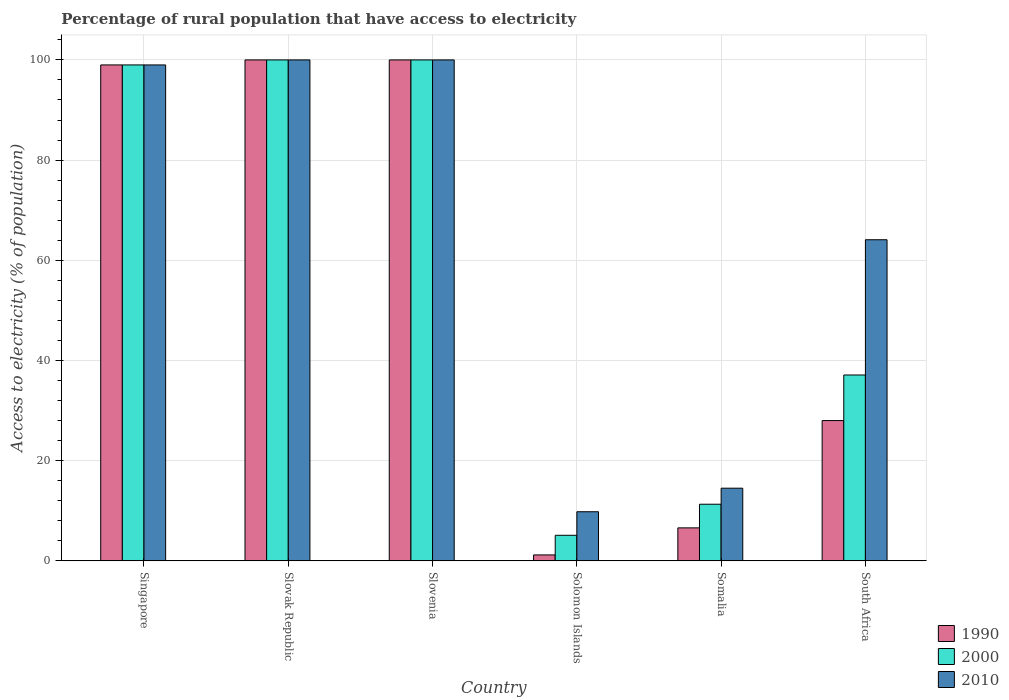How many different coloured bars are there?
Your answer should be compact. 3. How many groups of bars are there?
Provide a succinct answer. 6. How many bars are there on the 2nd tick from the left?
Your answer should be very brief. 3. What is the label of the 6th group of bars from the left?
Your response must be concise. South Africa. Across all countries, what is the minimum percentage of rural population that have access to electricity in 2010?
Provide a succinct answer. 9.8. In which country was the percentage of rural population that have access to electricity in 2010 maximum?
Offer a very short reply. Slovak Republic. In which country was the percentage of rural population that have access to electricity in 2010 minimum?
Ensure brevity in your answer.  Solomon Islands. What is the total percentage of rural population that have access to electricity in 1990 in the graph?
Ensure brevity in your answer.  334.76. What is the difference between the percentage of rural population that have access to electricity in 2010 in Slovenia and that in Somalia?
Keep it short and to the point. 85.5. What is the difference between the percentage of rural population that have access to electricity in 2010 in South Africa and the percentage of rural population that have access to electricity in 1990 in Slovak Republic?
Provide a succinct answer. -35.9. What is the average percentage of rural population that have access to electricity in 1990 per country?
Provide a succinct answer. 55.79. What is the difference between the percentage of rural population that have access to electricity of/in 2010 and percentage of rural population that have access to electricity of/in 2000 in Slovenia?
Make the answer very short. 0. What is the ratio of the percentage of rural population that have access to electricity in 2010 in Slovenia to that in Solomon Islands?
Offer a very short reply. 10.2. Is the percentage of rural population that have access to electricity in 2010 in Slovak Republic less than that in South Africa?
Your answer should be compact. No. Is the difference between the percentage of rural population that have access to electricity in 2010 in Somalia and South Africa greater than the difference between the percentage of rural population that have access to electricity in 2000 in Somalia and South Africa?
Your response must be concise. No. What is the difference between the highest and the second highest percentage of rural population that have access to electricity in 2010?
Your answer should be compact. -1. What is the difference between the highest and the lowest percentage of rural population that have access to electricity in 1990?
Provide a succinct answer. 98.82. What does the 2nd bar from the right in South Africa represents?
Your answer should be very brief. 2000. How many bars are there?
Your answer should be compact. 18. What is the difference between two consecutive major ticks on the Y-axis?
Make the answer very short. 20. Does the graph contain any zero values?
Your response must be concise. No. Where does the legend appear in the graph?
Offer a very short reply. Bottom right. What is the title of the graph?
Give a very brief answer. Percentage of rural population that have access to electricity. Does "1970" appear as one of the legend labels in the graph?
Ensure brevity in your answer.  No. What is the label or title of the X-axis?
Ensure brevity in your answer.  Country. What is the label or title of the Y-axis?
Your answer should be very brief. Access to electricity (% of population). What is the Access to electricity (% of population) of 1990 in Singapore?
Offer a terse response. 99. What is the Access to electricity (% of population) of 2000 in Singapore?
Make the answer very short. 99. What is the Access to electricity (% of population) of 2010 in Singapore?
Provide a succinct answer. 99. What is the Access to electricity (% of population) of 1990 in Slovak Republic?
Keep it short and to the point. 100. What is the Access to electricity (% of population) in 2000 in Slovak Republic?
Make the answer very short. 100. What is the Access to electricity (% of population) in 1990 in Slovenia?
Offer a very short reply. 100. What is the Access to electricity (% of population) of 1990 in Solomon Islands?
Keep it short and to the point. 1.18. What is the Access to electricity (% of population) in 2000 in Solomon Islands?
Provide a succinct answer. 5.1. What is the Access to electricity (% of population) in 2010 in Solomon Islands?
Give a very brief answer. 9.8. What is the Access to electricity (% of population) of 1990 in Somalia?
Your answer should be very brief. 6.58. What is the Access to electricity (% of population) in 2000 in Somalia?
Your response must be concise. 11.3. What is the Access to electricity (% of population) of 1990 in South Africa?
Your response must be concise. 28. What is the Access to electricity (% of population) in 2000 in South Africa?
Provide a succinct answer. 37.1. What is the Access to electricity (% of population) of 2010 in South Africa?
Make the answer very short. 64.1. Across all countries, what is the minimum Access to electricity (% of population) in 1990?
Your answer should be very brief. 1.18. Across all countries, what is the minimum Access to electricity (% of population) in 2000?
Give a very brief answer. 5.1. What is the total Access to electricity (% of population) in 1990 in the graph?
Ensure brevity in your answer.  334.76. What is the total Access to electricity (% of population) of 2000 in the graph?
Your answer should be very brief. 352.5. What is the total Access to electricity (% of population) in 2010 in the graph?
Your response must be concise. 387.4. What is the difference between the Access to electricity (% of population) of 1990 in Singapore and that in Slovak Republic?
Ensure brevity in your answer.  -1. What is the difference between the Access to electricity (% of population) of 2000 in Singapore and that in Slovak Republic?
Ensure brevity in your answer.  -1. What is the difference between the Access to electricity (% of population) in 2000 in Singapore and that in Slovenia?
Provide a succinct answer. -1. What is the difference between the Access to electricity (% of population) in 1990 in Singapore and that in Solomon Islands?
Your response must be concise. 97.82. What is the difference between the Access to electricity (% of population) in 2000 in Singapore and that in Solomon Islands?
Offer a very short reply. 93.9. What is the difference between the Access to electricity (% of population) of 2010 in Singapore and that in Solomon Islands?
Provide a succinct answer. 89.2. What is the difference between the Access to electricity (% of population) in 1990 in Singapore and that in Somalia?
Your answer should be very brief. 92.42. What is the difference between the Access to electricity (% of population) in 2000 in Singapore and that in Somalia?
Provide a succinct answer. 87.7. What is the difference between the Access to electricity (% of population) in 2010 in Singapore and that in Somalia?
Ensure brevity in your answer.  84.5. What is the difference between the Access to electricity (% of population) of 2000 in Singapore and that in South Africa?
Your response must be concise. 61.9. What is the difference between the Access to electricity (% of population) of 2010 in Singapore and that in South Africa?
Offer a terse response. 34.9. What is the difference between the Access to electricity (% of population) of 2000 in Slovak Republic and that in Slovenia?
Provide a succinct answer. 0. What is the difference between the Access to electricity (% of population) of 1990 in Slovak Republic and that in Solomon Islands?
Provide a short and direct response. 98.82. What is the difference between the Access to electricity (% of population) in 2000 in Slovak Republic and that in Solomon Islands?
Make the answer very short. 94.9. What is the difference between the Access to electricity (% of population) in 2010 in Slovak Republic and that in Solomon Islands?
Offer a terse response. 90.2. What is the difference between the Access to electricity (% of population) of 1990 in Slovak Republic and that in Somalia?
Offer a very short reply. 93.42. What is the difference between the Access to electricity (% of population) of 2000 in Slovak Republic and that in Somalia?
Offer a terse response. 88.7. What is the difference between the Access to electricity (% of population) of 2010 in Slovak Republic and that in Somalia?
Offer a very short reply. 85.5. What is the difference between the Access to electricity (% of population) of 2000 in Slovak Republic and that in South Africa?
Your response must be concise. 62.9. What is the difference between the Access to electricity (% of population) in 2010 in Slovak Republic and that in South Africa?
Offer a very short reply. 35.9. What is the difference between the Access to electricity (% of population) in 1990 in Slovenia and that in Solomon Islands?
Your answer should be compact. 98.82. What is the difference between the Access to electricity (% of population) of 2000 in Slovenia and that in Solomon Islands?
Provide a succinct answer. 94.9. What is the difference between the Access to electricity (% of population) of 2010 in Slovenia and that in Solomon Islands?
Keep it short and to the point. 90.2. What is the difference between the Access to electricity (% of population) of 1990 in Slovenia and that in Somalia?
Offer a terse response. 93.42. What is the difference between the Access to electricity (% of population) in 2000 in Slovenia and that in Somalia?
Provide a short and direct response. 88.7. What is the difference between the Access to electricity (% of population) of 2010 in Slovenia and that in Somalia?
Keep it short and to the point. 85.5. What is the difference between the Access to electricity (% of population) of 1990 in Slovenia and that in South Africa?
Give a very brief answer. 72. What is the difference between the Access to electricity (% of population) of 2000 in Slovenia and that in South Africa?
Your answer should be very brief. 62.9. What is the difference between the Access to electricity (% of population) in 2010 in Slovenia and that in South Africa?
Ensure brevity in your answer.  35.9. What is the difference between the Access to electricity (% of population) in 1990 in Solomon Islands and that in Somalia?
Your answer should be compact. -5.4. What is the difference between the Access to electricity (% of population) of 2000 in Solomon Islands and that in Somalia?
Your response must be concise. -6.2. What is the difference between the Access to electricity (% of population) in 2010 in Solomon Islands and that in Somalia?
Ensure brevity in your answer.  -4.7. What is the difference between the Access to electricity (% of population) in 1990 in Solomon Islands and that in South Africa?
Make the answer very short. -26.82. What is the difference between the Access to electricity (% of population) in 2000 in Solomon Islands and that in South Africa?
Your response must be concise. -32. What is the difference between the Access to electricity (% of population) in 2010 in Solomon Islands and that in South Africa?
Offer a terse response. -54.3. What is the difference between the Access to electricity (% of population) in 1990 in Somalia and that in South Africa?
Give a very brief answer. -21.42. What is the difference between the Access to electricity (% of population) of 2000 in Somalia and that in South Africa?
Provide a short and direct response. -25.8. What is the difference between the Access to electricity (% of population) of 2010 in Somalia and that in South Africa?
Your answer should be compact. -49.6. What is the difference between the Access to electricity (% of population) in 1990 in Singapore and the Access to electricity (% of population) in 2010 in Slovak Republic?
Give a very brief answer. -1. What is the difference between the Access to electricity (% of population) in 1990 in Singapore and the Access to electricity (% of population) in 2010 in Slovenia?
Make the answer very short. -1. What is the difference between the Access to electricity (% of population) in 2000 in Singapore and the Access to electricity (% of population) in 2010 in Slovenia?
Your answer should be compact. -1. What is the difference between the Access to electricity (% of population) in 1990 in Singapore and the Access to electricity (% of population) in 2000 in Solomon Islands?
Provide a short and direct response. 93.9. What is the difference between the Access to electricity (% of population) of 1990 in Singapore and the Access to electricity (% of population) of 2010 in Solomon Islands?
Offer a very short reply. 89.2. What is the difference between the Access to electricity (% of population) in 2000 in Singapore and the Access to electricity (% of population) in 2010 in Solomon Islands?
Your response must be concise. 89.2. What is the difference between the Access to electricity (% of population) in 1990 in Singapore and the Access to electricity (% of population) in 2000 in Somalia?
Your answer should be very brief. 87.7. What is the difference between the Access to electricity (% of population) of 1990 in Singapore and the Access to electricity (% of population) of 2010 in Somalia?
Offer a very short reply. 84.5. What is the difference between the Access to electricity (% of population) of 2000 in Singapore and the Access to electricity (% of population) of 2010 in Somalia?
Keep it short and to the point. 84.5. What is the difference between the Access to electricity (% of population) in 1990 in Singapore and the Access to electricity (% of population) in 2000 in South Africa?
Keep it short and to the point. 61.9. What is the difference between the Access to electricity (% of population) in 1990 in Singapore and the Access to electricity (% of population) in 2010 in South Africa?
Your answer should be very brief. 34.9. What is the difference between the Access to electricity (% of population) in 2000 in Singapore and the Access to electricity (% of population) in 2010 in South Africa?
Offer a terse response. 34.9. What is the difference between the Access to electricity (% of population) in 1990 in Slovak Republic and the Access to electricity (% of population) in 2000 in Solomon Islands?
Your answer should be compact. 94.9. What is the difference between the Access to electricity (% of population) in 1990 in Slovak Republic and the Access to electricity (% of population) in 2010 in Solomon Islands?
Give a very brief answer. 90.2. What is the difference between the Access to electricity (% of population) in 2000 in Slovak Republic and the Access to electricity (% of population) in 2010 in Solomon Islands?
Give a very brief answer. 90.2. What is the difference between the Access to electricity (% of population) of 1990 in Slovak Republic and the Access to electricity (% of population) of 2000 in Somalia?
Provide a short and direct response. 88.7. What is the difference between the Access to electricity (% of population) in 1990 in Slovak Republic and the Access to electricity (% of population) in 2010 in Somalia?
Give a very brief answer. 85.5. What is the difference between the Access to electricity (% of population) of 2000 in Slovak Republic and the Access to electricity (% of population) of 2010 in Somalia?
Offer a terse response. 85.5. What is the difference between the Access to electricity (% of population) of 1990 in Slovak Republic and the Access to electricity (% of population) of 2000 in South Africa?
Your answer should be very brief. 62.9. What is the difference between the Access to electricity (% of population) of 1990 in Slovak Republic and the Access to electricity (% of population) of 2010 in South Africa?
Your answer should be compact. 35.9. What is the difference between the Access to electricity (% of population) of 2000 in Slovak Republic and the Access to electricity (% of population) of 2010 in South Africa?
Provide a short and direct response. 35.9. What is the difference between the Access to electricity (% of population) of 1990 in Slovenia and the Access to electricity (% of population) of 2000 in Solomon Islands?
Make the answer very short. 94.9. What is the difference between the Access to electricity (% of population) of 1990 in Slovenia and the Access to electricity (% of population) of 2010 in Solomon Islands?
Provide a succinct answer. 90.2. What is the difference between the Access to electricity (% of population) of 2000 in Slovenia and the Access to electricity (% of population) of 2010 in Solomon Islands?
Your answer should be compact. 90.2. What is the difference between the Access to electricity (% of population) of 1990 in Slovenia and the Access to electricity (% of population) of 2000 in Somalia?
Provide a succinct answer. 88.7. What is the difference between the Access to electricity (% of population) in 1990 in Slovenia and the Access to electricity (% of population) in 2010 in Somalia?
Offer a terse response. 85.5. What is the difference between the Access to electricity (% of population) of 2000 in Slovenia and the Access to electricity (% of population) of 2010 in Somalia?
Keep it short and to the point. 85.5. What is the difference between the Access to electricity (% of population) in 1990 in Slovenia and the Access to electricity (% of population) in 2000 in South Africa?
Your response must be concise. 62.9. What is the difference between the Access to electricity (% of population) in 1990 in Slovenia and the Access to electricity (% of population) in 2010 in South Africa?
Provide a short and direct response. 35.9. What is the difference between the Access to electricity (% of population) of 2000 in Slovenia and the Access to electricity (% of population) of 2010 in South Africa?
Give a very brief answer. 35.9. What is the difference between the Access to electricity (% of population) in 1990 in Solomon Islands and the Access to electricity (% of population) in 2000 in Somalia?
Offer a terse response. -10.12. What is the difference between the Access to electricity (% of population) in 1990 in Solomon Islands and the Access to electricity (% of population) in 2010 in Somalia?
Your response must be concise. -13.32. What is the difference between the Access to electricity (% of population) in 2000 in Solomon Islands and the Access to electricity (% of population) in 2010 in Somalia?
Your answer should be compact. -9.4. What is the difference between the Access to electricity (% of population) in 1990 in Solomon Islands and the Access to electricity (% of population) in 2000 in South Africa?
Make the answer very short. -35.92. What is the difference between the Access to electricity (% of population) of 1990 in Solomon Islands and the Access to electricity (% of population) of 2010 in South Africa?
Keep it short and to the point. -62.92. What is the difference between the Access to electricity (% of population) in 2000 in Solomon Islands and the Access to electricity (% of population) in 2010 in South Africa?
Your answer should be compact. -59. What is the difference between the Access to electricity (% of population) of 1990 in Somalia and the Access to electricity (% of population) of 2000 in South Africa?
Provide a succinct answer. -30.52. What is the difference between the Access to electricity (% of population) in 1990 in Somalia and the Access to electricity (% of population) in 2010 in South Africa?
Provide a succinct answer. -57.52. What is the difference between the Access to electricity (% of population) of 2000 in Somalia and the Access to electricity (% of population) of 2010 in South Africa?
Your answer should be very brief. -52.8. What is the average Access to electricity (% of population) in 1990 per country?
Make the answer very short. 55.79. What is the average Access to electricity (% of population) of 2000 per country?
Your response must be concise. 58.75. What is the average Access to electricity (% of population) of 2010 per country?
Make the answer very short. 64.57. What is the difference between the Access to electricity (% of population) in 1990 and Access to electricity (% of population) in 2000 in Slovak Republic?
Your answer should be very brief. 0. What is the difference between the Access to electricity (% of population) of 2000 and Access to electricity (% of population) of 2010 in Slovak Republic?
Your answer should be compact. 0. What is the difference between the Access to electricity (% of population) of 1990 and Access to electricity (% of population) of 2000 in Solomon Islands?
Provide a short and direct response. -3.92. What is the difference between the Access to electricity (% of population) of 1990 and Access to electricity (% of population) of 2010 in Solomon Islands?
Give a very brief answer. -8.62. What is the difference between the Access to electricity (% of population) in 1990 and Access to electricity (% of population) in 2000 in Somalia?
Your response must be concise. -4.72. What is the difference between the Access to electricity (% of population) in 1990 and Access to electricity (% of population) in 2010 in Somalia?
Provide a short and direct response. -7.92. What is the difference between the Access to electricity (% of population) in 2000 and Access to electricity (% of population) in 2010 in Somalia?
Your answer should be compact. -3.2. What is the difference between the Access to electricity (% of population) in 1990 and Access to electricity (% of population) in 2010 in South Africa?
Ensure brevity in your answer.  -36.1. What is the difference between the Access to electricity (% of population) in 2000 and Access to electricity (% of population) in 2010 in South Africa?
Your response must be concise. -27. What is the ratio of the Access to electricity (% of population) in 1990 in Singapore to that in Slovak Republic?
Provide a short and direct response. 0.99. What is the ratio of the Access to electricity (% of population) of 2010 in Singapore to that in Slovak Republic?
Your answer should be compact. 0.99. What is the ratio of the Access to electricity (% of population) in 1990 in Singapore to that in Solomon Islands?
Offer a terse response. 83.94. What is the ratio of the Access to electricity (% of population) in 2000 in Singapore to that in Solomon Islands?
Offer a very short reply. 19.41. What is the ratio of the Access to electricity (% of population) of 2010 in Singapore to that in Solomon Islands?
Your answer should be very brief. 10.1. What is the ratio of the Access to electricity (% of population) in 1990 in Singapore to that in Somalia?
Keep it short and to the point. 15.05. What is the ratio of the Access to electricity (% of population) in 2000 in Singapore to that in Somalia?
Provide a succinct answer. 8.76. What is the ratio of the Access to electricity (% of population) in 2010 in Singapore to that in Somalia?
Your response must be concise. 6.83. What is the ratio of the Access to electricity (% of population) of 1990 in Singapore to that in South Africa?
Your answer should be compact. 3.54. What is the ratio of the Access to electricity (% of population) in 2000 in Singapore to that in South Africa?
Your response must be concise. 2.67. What is the ratio of the Access to electricity (% of population) in 2010 in Singapore to that in South Africa?
Offer a terse response. 1.54. What is the ratio of the Access to electricity (% of population) in 1990 in Slovak Republic to that in Solomon Islands?
Your answer should be compact. 84.78. What is the ratio of the Access to electricity (% of population) of 2000 in Slovak Republic to that in Solomon Islands?
Your answer should be compact. 19.61. What is the ratio of the Access to electricity (% of population) in 2010 in Slovak Republic to that in Solomon Islands?
Provide a short and direct response. 10.2. What is the ratio of the Access to electricity (% of population) in 1990 in Slovak Republic to that in Somalia?
Ensure brevity in your answer.  15.2. What is the ratio of the Access to electricity (% of population) of 2000 in Slovak Republic to that in Somalia?
Provide a short and direct response. 8.85. What is the ratio of the Access to electricity (% of population) in 2010 in Slovak Republic to that in Somalia?
Make the answer very short. 6.9. What is the ratio of the Access to electricity (% of population) of 1990 in Slovak Republic to that in South Africa?
Your answer should be compact. 3.57. What is the ratio of the Access to electricity (% of population) in 2000 in Slovak Republic to that in South Africa?
Your response must be concise. 2.7. What is the ratio of the Access to electricity (% of population) in 2010 in Slovak Republic to that in South Africa?
Make the answer very short. 1.56. What is the ratio of the Access to electricity (% of population) of 1990 in Slovenia to that in Solomon Islands?
Your answer should be very brief. 84.78. What is the ratio of the Access to electricity (% of population) of 2000 in Slovenia to that in Solomon Islands?
Your answer should be compact. 19.61. What is the ratio of the Access to electricity (% of population) of 2010 in Slovenia to that in Solomon Islands?
Offer a very short reply. 10.2. What is the ratio of the Access to electricity (% of population) in 1990 in Slovenia to that in Somalia?
Ensure brevity in your answer.  15.2. What is the ratio of the Access to electricity (% of population) in 2000 in Slovenia to that in Somalia?
Your answer should be very brief. 8.85. What is the ratio of the Access to electricity (% of population) in 2010 in Slovenia to that in Somalia?
Keep it short and to the point. 6.9. What is the ratio of the Access to electricity (% of population) in 1990 in Slovenia to that in South Africa?
Keep it short and to the point. 3.57. What is the ratio of the Access to electricity (% of population) in 2000 in Slovenia to that in South Africa?
Your answer should be very brief. 2.7. What is the ratio of the Access to electricity (% of population) of 2010 in Slovenia to that in South Africa?
Offer a very short reply. 1.56. What is the ratio of the Access to electricity (% of population) in 1990 in Solomon Islands to that in Somalia?
Your response must be concise. 0.18. What is the ratio of the Access to electricity (% of population) in 2000 in Solomon Islands to that in Somalia?
Keep it short and to the point. 0.45. What is the ratio of the Access to electricity (% of population) of 2010 in Solomon Islands to that in Somalia?
Your answer should be very brief. 0.68. What is the ratio of the Access to electricity (% of population) of 1990 in Solomon Islands to that in South Africa?
Keep it short and to the point. 0.04. What is the ratio of the Access to electricity (% of population) of 2000 in Solomon Islands to that in South Africa?
Give a very brief answer. 0.14. What is the ratio of the Access to electricity (% of population) of 2010 in Solomon Islands to that in South Africa?
Your answer should be compact. 0.15. What is the ratio of the Access to electricity (% of population) of 1990 in Somalia to that in South Africa?
Your answer should be very brief. 0.23. What is the ratio of the Access to electricity (% of population) of 2000 in Somalia to that in South Africa?
Your answer should be very brief. 0.3. What is the ratio of the Access to electricity (% of population) in 2010 in Somalia to that in South Africa?
Offer a very short reply. 0.23. What is the difference between the highest and the second highest Access to electricity (% of population) of 1990?
Your answer should be very brief. 0. What is the difference between the highest and the second highest Access to electricity (% of population) in 2000?
Make the answer very short. 0. What is the difference between the highest and the lowest Access to electricity (% of population) in 1990?
Offer a very short reply. 98.82. What is the difference between the highest and the lowest Access to electricity (% of population) of 2000?
Offer a terse response. 94.9. What is the difference between the highest and the lowest Access to electricity (% of population) in 2010?
Make the answer very short. 90.2. 